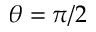<formula> <loc_0><loc_0><loc_500><loc_500>\theta = \pi / 2</formula> 